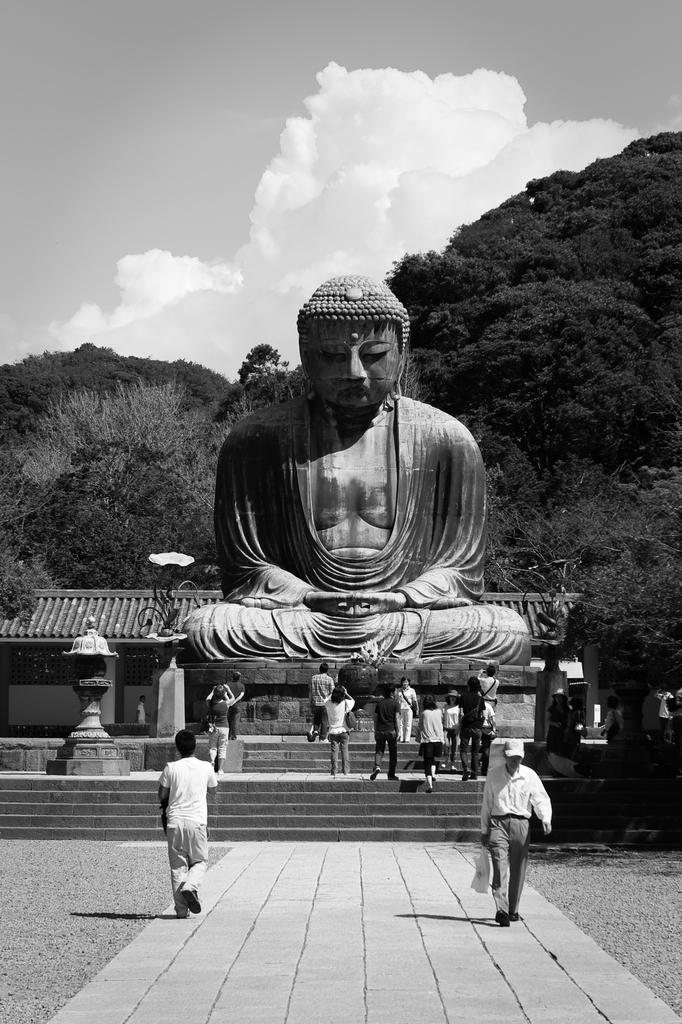In one or two sentences, can you explain what this image depicts? In this image I can see the statue. In-front of the statue there are many people standing. To the left I can see the shed. In the background there is a mountain, clouds and the sky. 